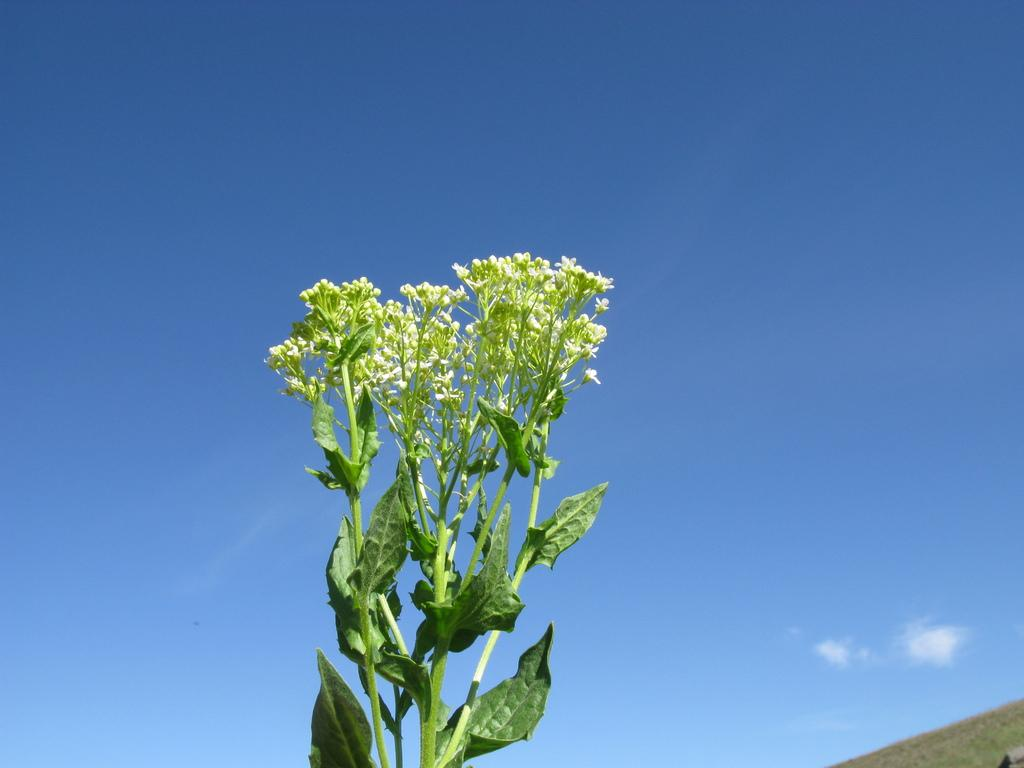What type of plant is in the center of the image? There is a plant with leaves and flowers in the image. Can you describe the location of the plant in the image? The plant is in the center of the image. What can be seen in the background of the image? There is a hill and the sky visible in the background of the image. How would you describe the sky in the image? The sky appears cloudy in the image. What type of wire is used to hold the eggnog in the image? There is no wire or eggnog present in the image; it features a plant with leaves and flowers, a hill, and a cloudy sky in the background. 